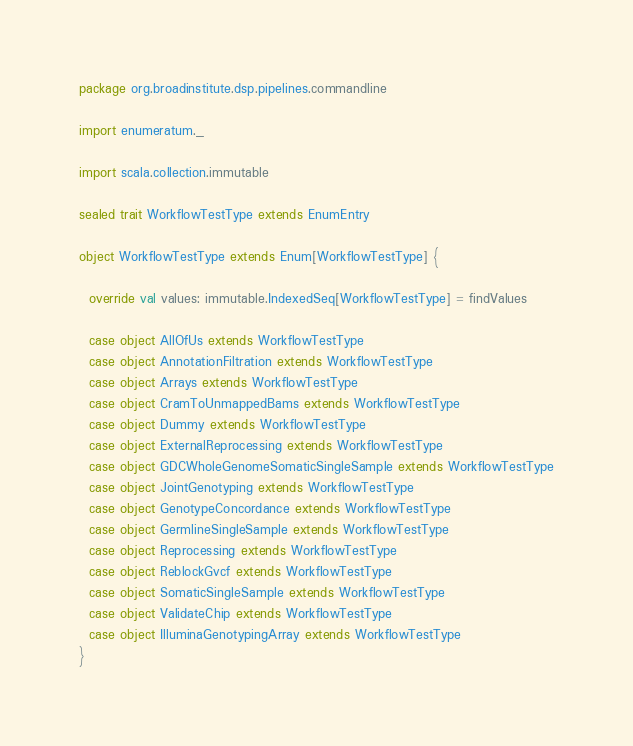<code> <loc_0><loc_0><loc_500><loc_500><_Scala_>package org.broadinstitute.dsp.pipelines.commandline

import enumeratum._

import scala.collection.immutable

sealed trait WorkflowTestType extends EnumEntry

object WorkflowTestType extends Enum[WorkflowTestType] {

  override val values: immutable.IndexedSeq[WorkflowTestType] = findValues

  case object AllOfUs extends WorkflowTestType
  case object AnnotationFiltration extends WorkflowTestType
  case object Arrays extends WorkflowTestType
  case object CramToUnmappedBams extends WorkflowTestType
  case object Dummy extends WorkflowTestType
  case object ExternalReprocessing extends WorkflowTestType
  case object GDCWholeGenomeSomaticSingleSample extends WorkflowTestType
  case object JointGenotyping extends WorkflowTestType
  case object GenotypeConcordance extends WorkflowTestType
  case object GermlineSingleSample extends WorkflowTestType
  case object Reprocessing extends WorkflowTestType
  case object ReblockGvcf extends WorkflowTestType
  case object SomaticSingleSample extends WorkflowTestType
  case object ValidateChip extends WorkflowTestType
  case object IlluminaGenotypingArray extends WorkflowTestType
}
</code> 